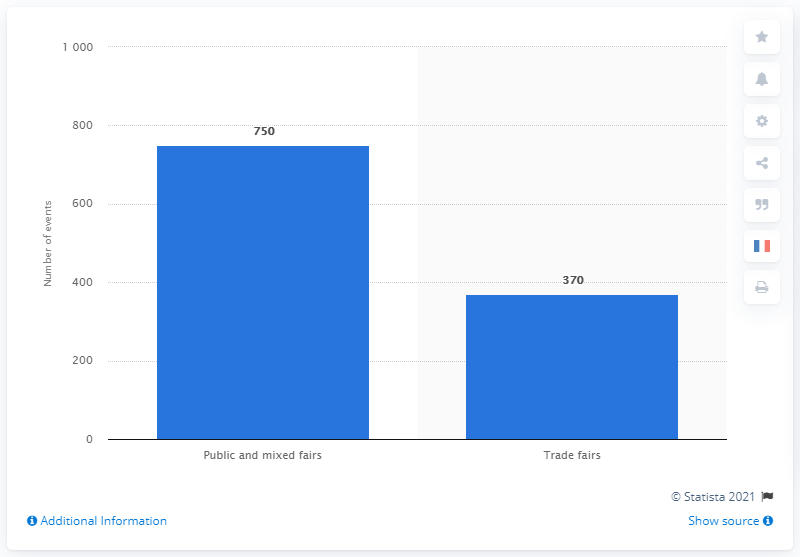Highlight a few significant elements in this photo. There were 370 trade fairs held in France in 2018. 